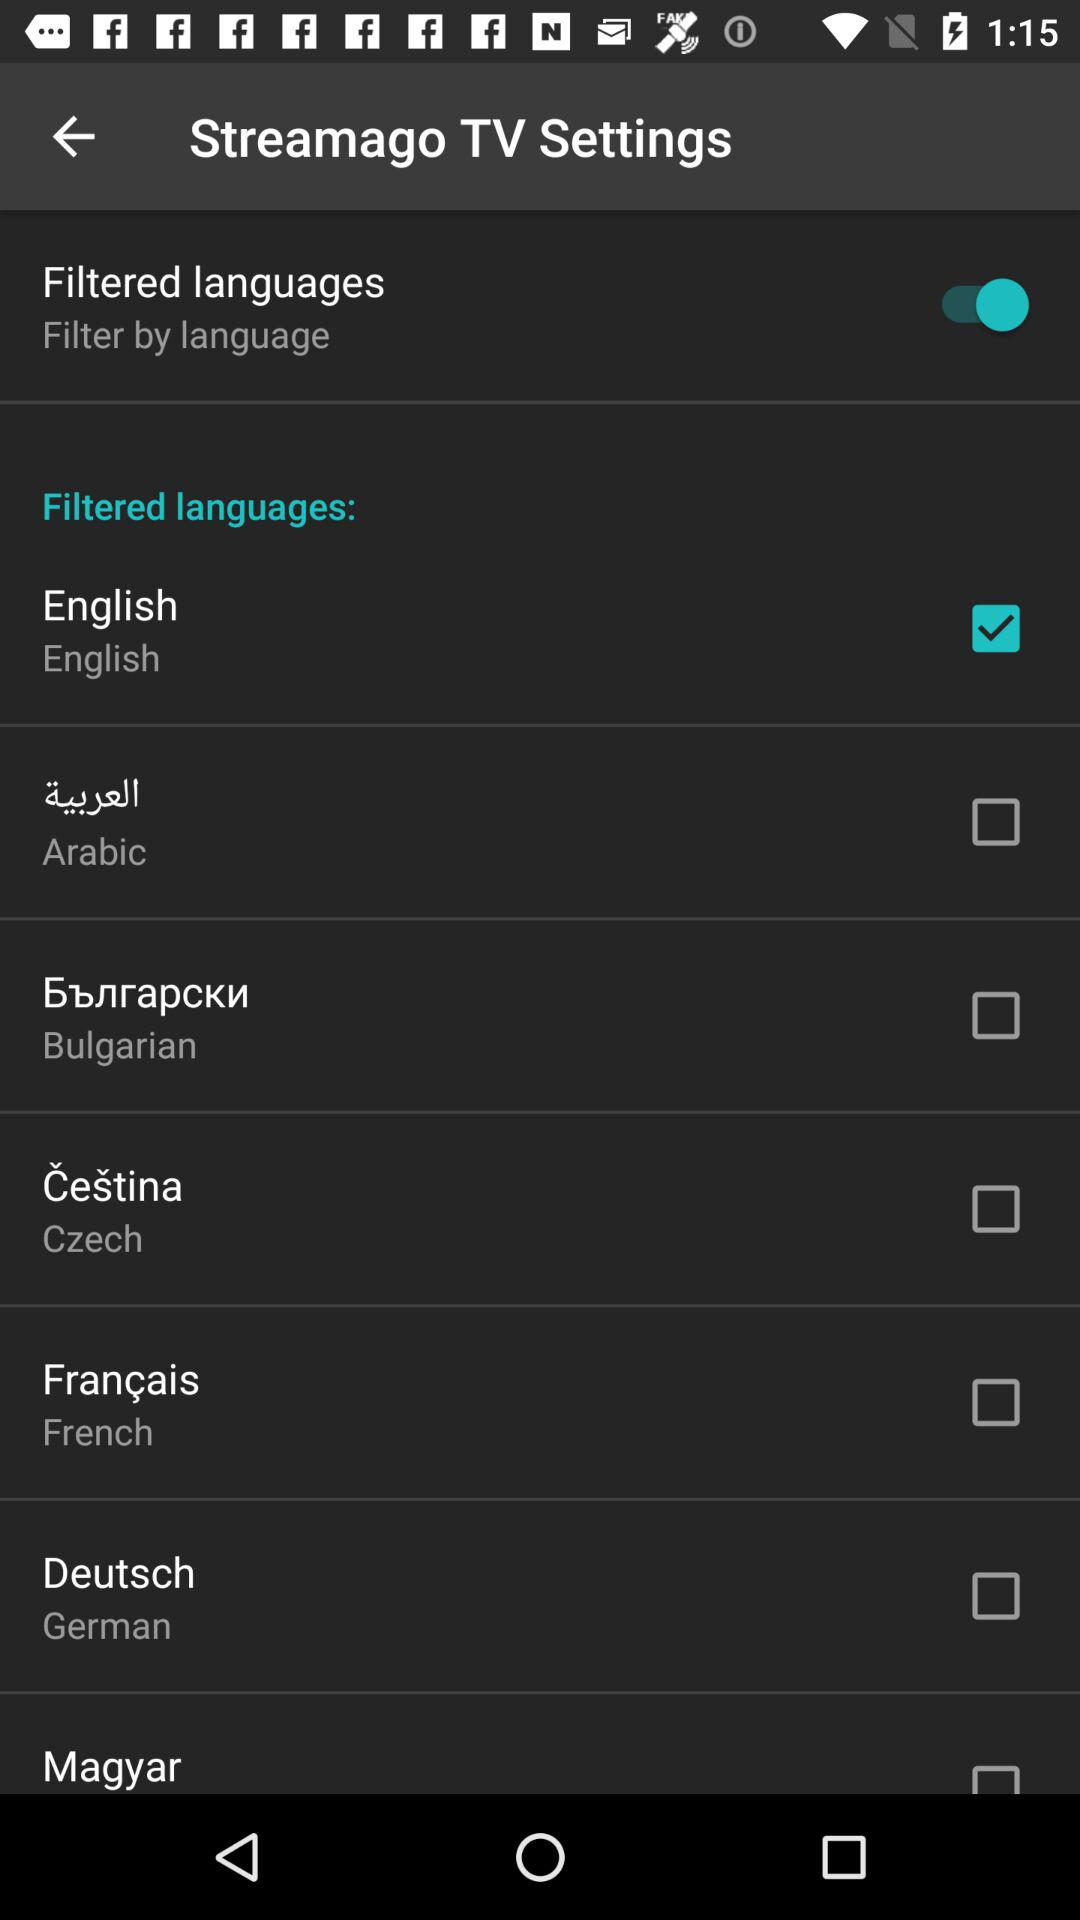What is the application name? The application name is "Streamago". 